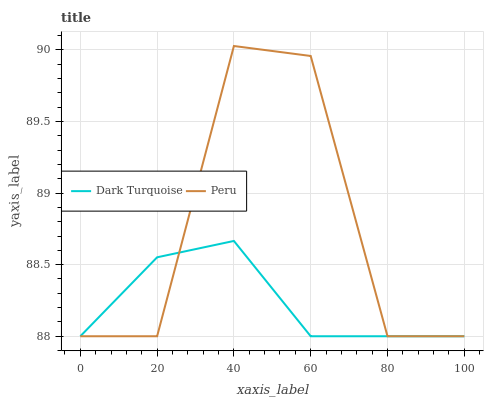Does Dark Turquoise have the minimum area under the curve?
Answer yes or no. Yes. Does Peru have the maximum area under the curve?
Answer yes or no. Yes. Does Peru have the minimum area under the curve?
Answer yes or no. No. Is Dark Turquoise the smoothest?
Answer yes or no. Yes. Is Peru the roughest?
Answer yes or no. Yes. Is Peru the smoothest?
Answer yes or no. No. Does Dark Turquoise have the lowest value?
Answer yes or no. Yes. Does Peru have the highest value?
Answer yes or no. Yes. Does Dark Turquoise intersect Peru?
Answer yes or no. Yes. Is Dark Turquoise less than Peru?
Answer yes or no. No. Is Dark Turquoise greater than Peru?
Answer yes or no. No. 